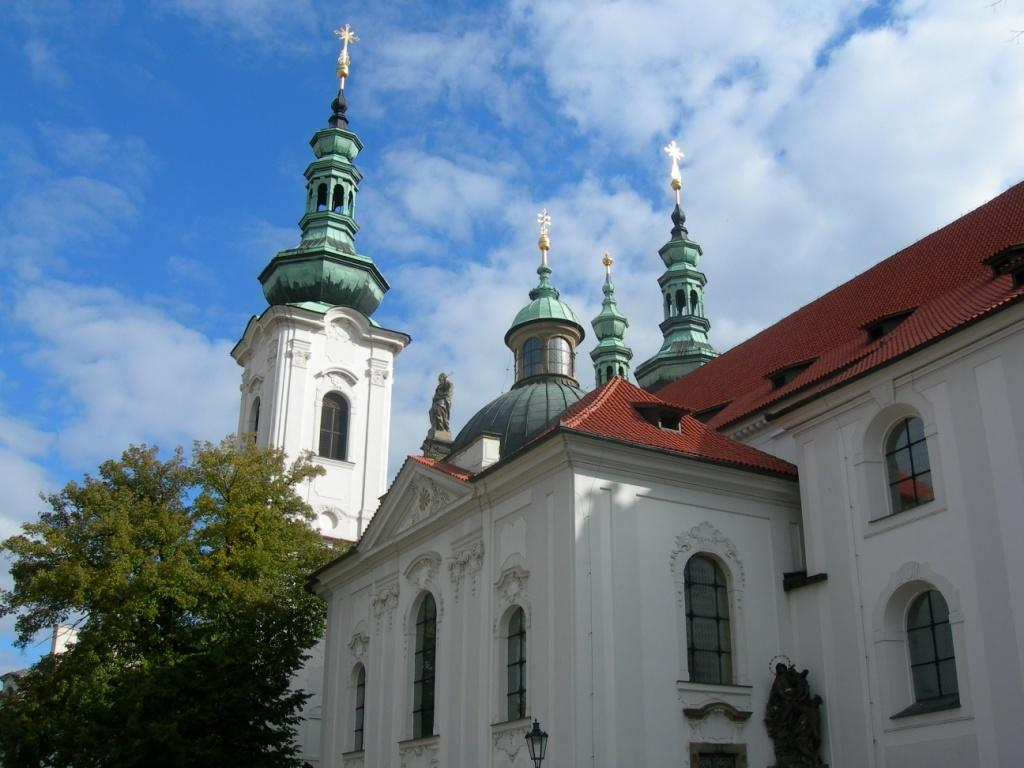What type of structure is visible in the image? There is a building in the image. What feature can be seen on the building? The building has windows. What is the other object visible in the image? There is a light-pole in the image. What type of vegetation is present in the image? There are trees in the image. What is the color of the sky in the image? The sky is blue and white in color. Can you tell me how many elbows are visible in the image? There are no elbows present in the image. What type of poison is being used in the image? There is no poison present in the image. 